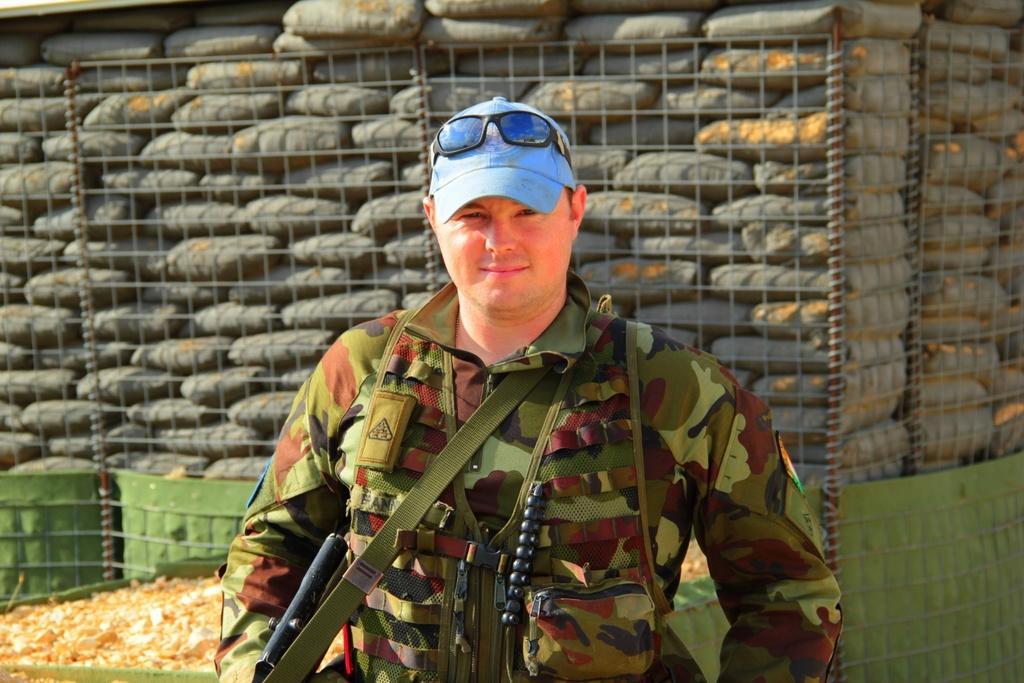Describe this image in one or two sentences. In this image there is a man standing. He is smiling. He is holding a gun in his hand. He seems to be a soldier. Behind him there are bags. There is a fence around the bags. 